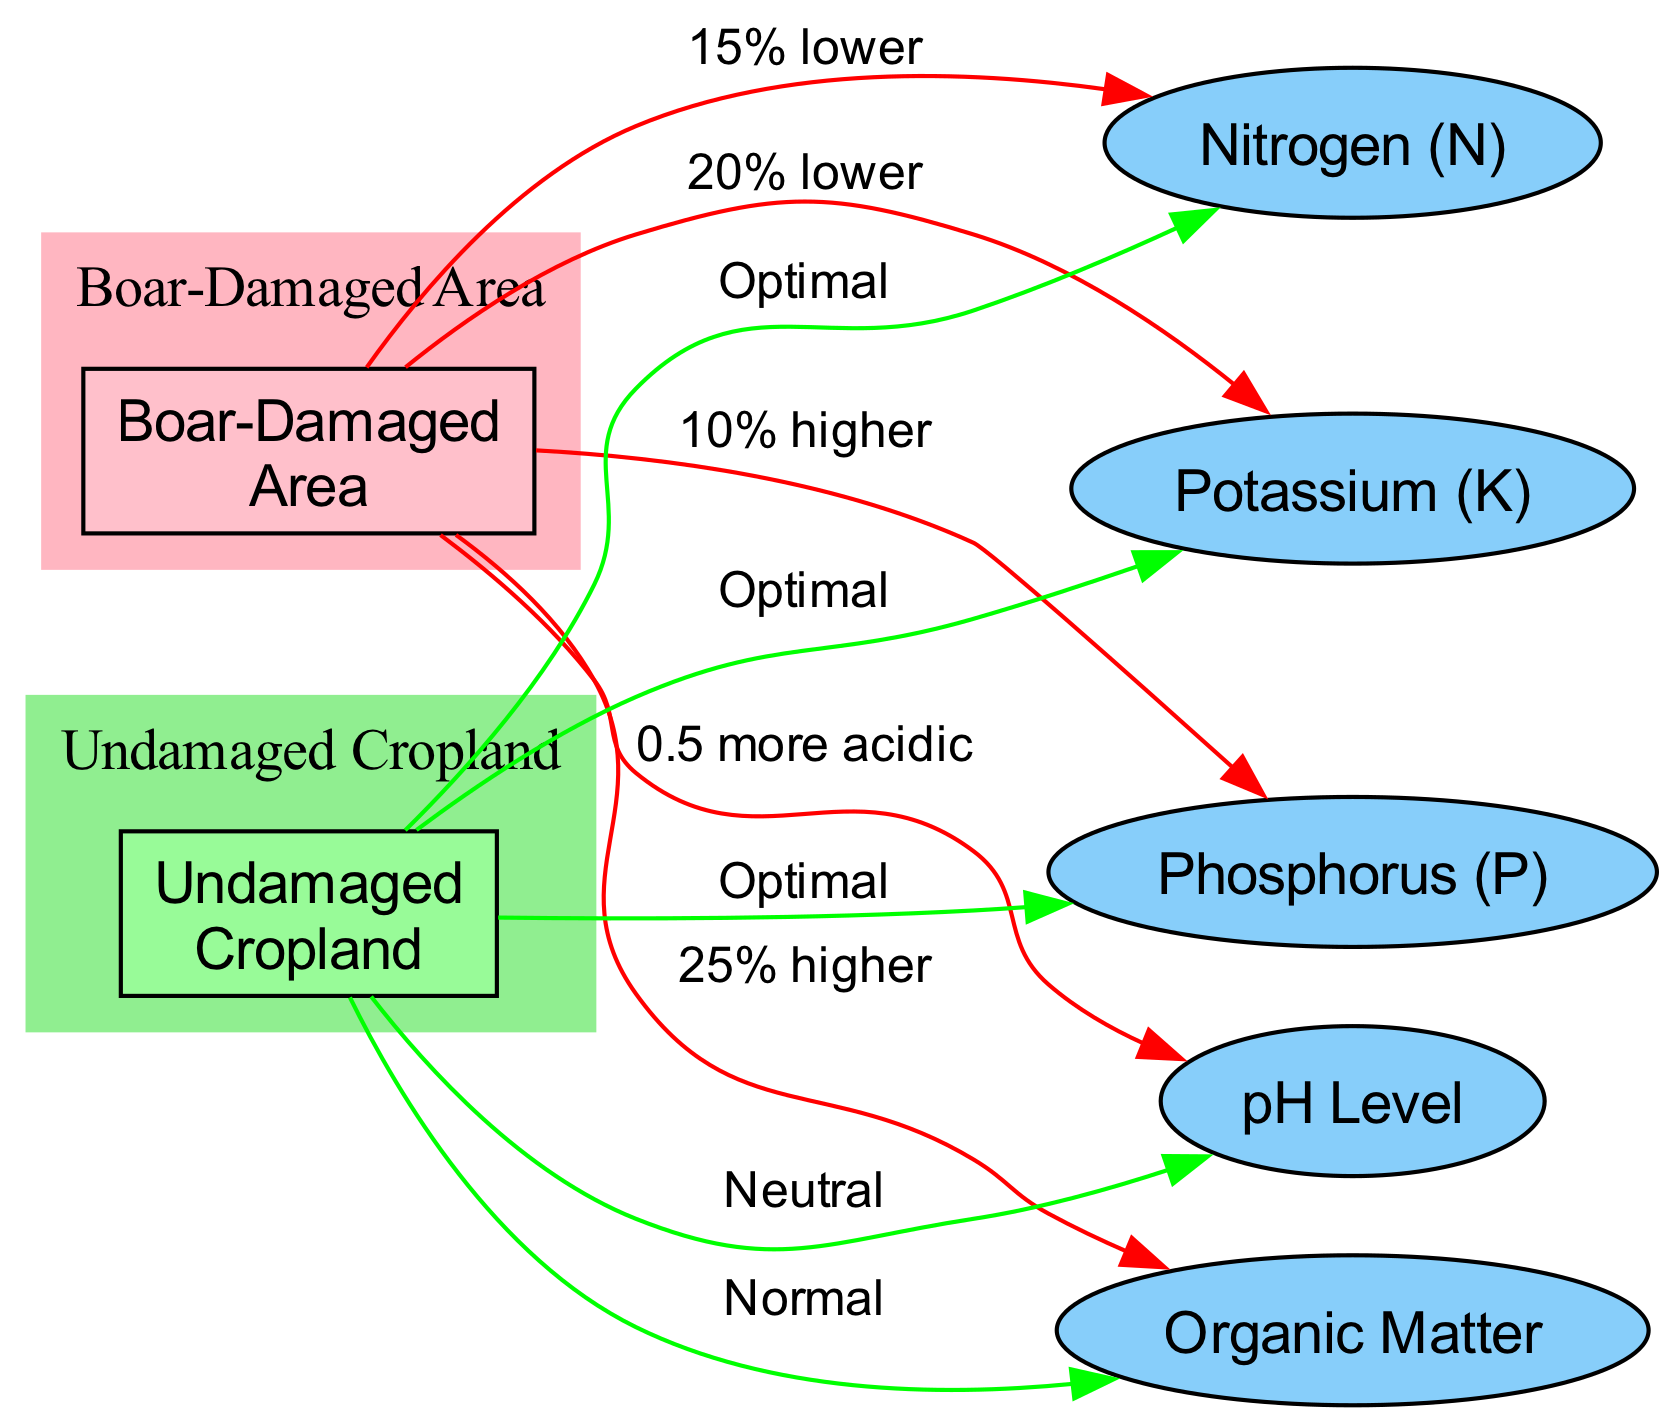What is the nitrogen level in the boar-damaged area? The diagram indicates that the nitrogen level in the boar-damaged area is 15% lower compared to the undamaged cropland, which has an optimal nitrogen level. Therefore, the nitrogen level in the boar-damaged area must be lower than optimal.
Answer: 15% lower How much higher is the phosphorus level in the boar-damaged area compared to the undamaged cropland? According to the diagram, the phosphorus level in the boar-damaged area is 10% higher than in the undamaged cropland, where the phosphorus level is also optimal. This indicates that the boar-damaged area has an increased level of phosphorus compared to the undamaged area.
Answer: 10% higher What is the potassium level in the undamaged cropland? The diagram shows that the potassium level in the undamaged cropland is labeled as optimal. As there are no specific values provided, we can conclude that the potassium level is at an optimal standard.
Answer: Optimal What percentage higher is the organic matter in the boar-damaged area compared to the undamaged cropland? The diagram specifies that organic matter is 25% higher in the boar-damaged area. This information is provided directly in the connection between the boar-damaged area node and the organic matter node.
Answer: 25% higher If the pH level in the undamaged cropland is neutral, by how much is the pH in the boar-damaged area more acidic? The diagram indicates that the pH level in the boar-damaged area is 0.5 more acidic compared to the neutral pH level of the undamaged cropland. We can observe this information directly from the connection to the pH level node.
Answer: 0.5 more acidic What is the relationship between potassium levels in both areas? The diagram states that the potassium level in the boar-damaged area is 20% lower than the optimal level found in the undamaged cropland, indicating a negative relationship regarding potassium levels between the two areas.
Answer: 20% lower How many nodes are depicted in the diagram? The diagram includes a total of 7 nodes, which consist of 2 areas (boar-damaged and undamaged), and 5 soil components. By counting each unique node in the diagram, we arrive at the total.
Answer: 7 nodes What does the color of the boar-damaged area signify? The color pink used for the boar-damaged area signifies that this area is affected by damage, as per the visual representation guidelines followed in the diagram.
Answer: Pink What do the colors of the nodes indicate about their condition? In the diagram, the boar-damaged area nodes are colored in shades of pink, indicating damage or poorer conditions, while the undamaged cropland nodes are in light green, suggesting a healthy or optimal condition.
Answer: Pink for damaged, green for healthy 